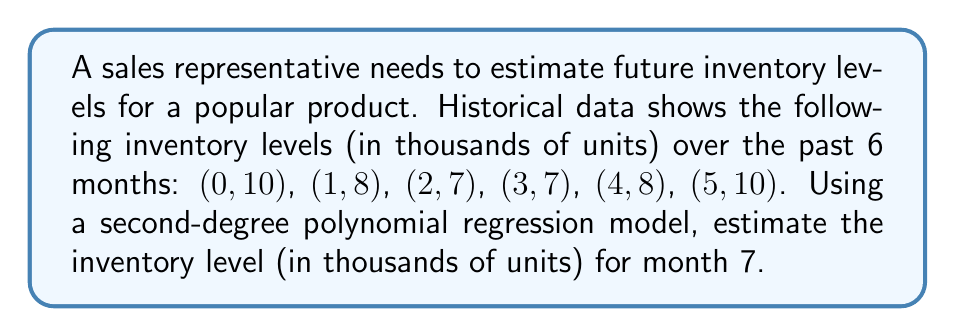Show me your answer to this math problem. To estimate future inventory levels using polynomial regression, we'll follow these steps:

1) For a second-degree polynomial, we use the model: $y = ax^2 + bx + c$

2) We need to solve for $a$, $b$, and $c$ using the given data points. We can use the normal equations:

   $$\begin{bmatrix}
   \sum x^4 & \sum x^3 & \sum x^2 \\
   \sum x^3 & \sum x^2 & \sum x \\
   \sum x^2 & \sum x & n
   \end{bmatrix}
   \begin{bmatrix}
   a \\ b \\ c
   \end{bmatrix} =
   \begin{bmatrix}
   \sum x^2y \\ \sum xy \\ \sum y
   \end{bmatrix}$$

3) Calculate the sums:
   $\sum x^4 = 354$, $\sum x^3 = 225$, $\sum x^2 = 55$, $\sum x = 15$, $n = 6$
   $\sum x^2y = 170$, $\sum xy = 115$, $\sum y = 50$

4) Substituting into the matrix equation:

   $$\begin{bmatrix}
   354 & 225 & 55 \\
   225 & 55 & 15 \\
   55 & 15 & 6
   \end{bmatrix}
   \begin{bmatrix}
   a \\ b \\ c
   \end{bmatrix} =
   \begin{bmatrix}
   170 \\ 115 \\ 50
   \end{bmatrix}$$

5) Solve this system of equations to get:
   $a = 0.4$, $b = -2.5$, $c = 10$

6) Our polynomial regression model is:
   $y = 0.4x^2 - 2.5x + 10$

7) To estimate the inventory level for month 7, substitute $x = 7$:
   $y = 0.4(7^2) - 2.5(7) + 10 = 19.6 - 17.5 + 10 = 12.1$

Therefore, the estimated inventory level for month 7 is 12.1 thousand units.
Answer: 12.1 thousand units 